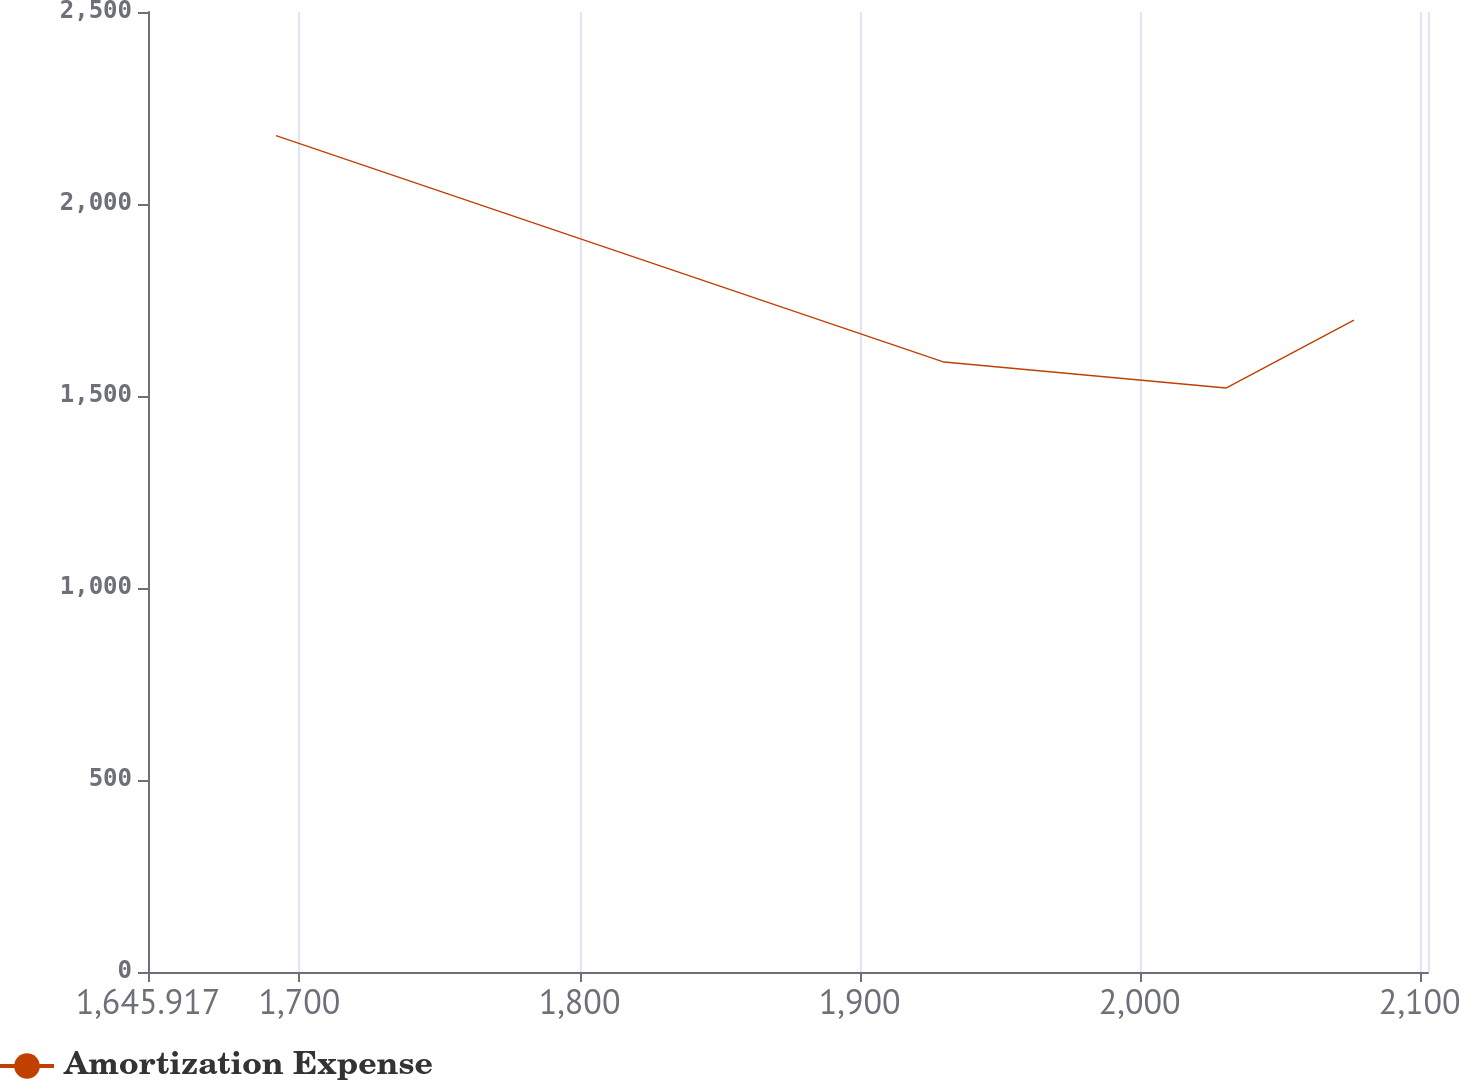Convert chart to OTSL. <chart><loc_0><loc_0><loc_500><loc_500><line_chart><ecel><fcel>Amortization Expense<nl><fcel>1691.62<fcel>2177.95<nl><fcel>1930.16<fcel>1588.44<nl><fcel>2030.8<fcel>1520.71<nl><fcel>2076.5<fcel>1697.57<nl><fcel>2148.65<fcel>1955.68<nl></chart> 